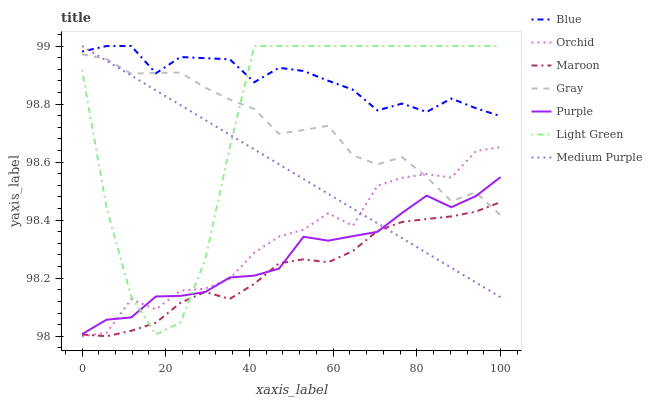Does Maroon have the minimum area under the curve?
Answer yes or no. Yes. Does Blue have the maximum area under the curve?
Answer yes or no. Yes. Does Gray have the minimum area under the curve?
Answer yes or no. No. Does Gray have the maximum area under the curve?
Answer yes or no. No. Is Medium Purple the smoothest?
Answer yes or no. Yes. Is Light Green the roughest?
Answer yes or no. Yes. Is Gray the smoothest?
Answer yes or no. No. Is Gray the roughest?
Answer yes or no. No. Does Maroon have the lowest value?
Answer yes or no. Yes. Does Gray have the lowest value?
Answer yes or no. No. Does Light Green have the highest value?
Answer yes or no. Yes. Does Gray have the highest value?
Answer yes or no. No. Is Maroon less than Blue?
Answer yes or no. Yes. Is Blue greater than Maroon?
Answer yes or no. Yes. Does Gray intersect Purple?
Answer yes or no. Yes. Is Gray less than Purple?
Answer yes or no. No. Is Gray greater than Purple?
Answer yes or no. No. Does Maroon intersect Blue?
Answer yes or no. No. 